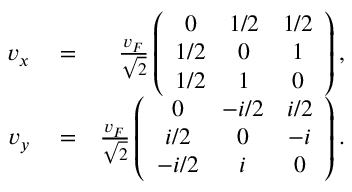<formula> <loc_0><loc_0><loc_500><loc_500>\begin{array} { r l r } { v _ { x } } & = } & { \frac { v _ { F } } { \sqrt { 2 } } \left ( \begin{array} { c c c } { 0 } & { 1 / 2 } & { 1 / 2 } \\ { 1 / 2 } & { 0 } & { 1 } \\ { 1 / 2 } & { 1 } & { 0 } \end{array} \right ) , } \\ { v _ { y } } & = } & { \frac { v _ { F } } { \sqrt { 2 } } \left ( \begin{array} { c c c } { 0 } & { - i / 2 } & { i / 2 } \\ { i / 2 } & { 0 } & { - i } \\ { - i / 2 } & { i } & { 0 } \end{array} \right ) . } \end{array}</formula> 